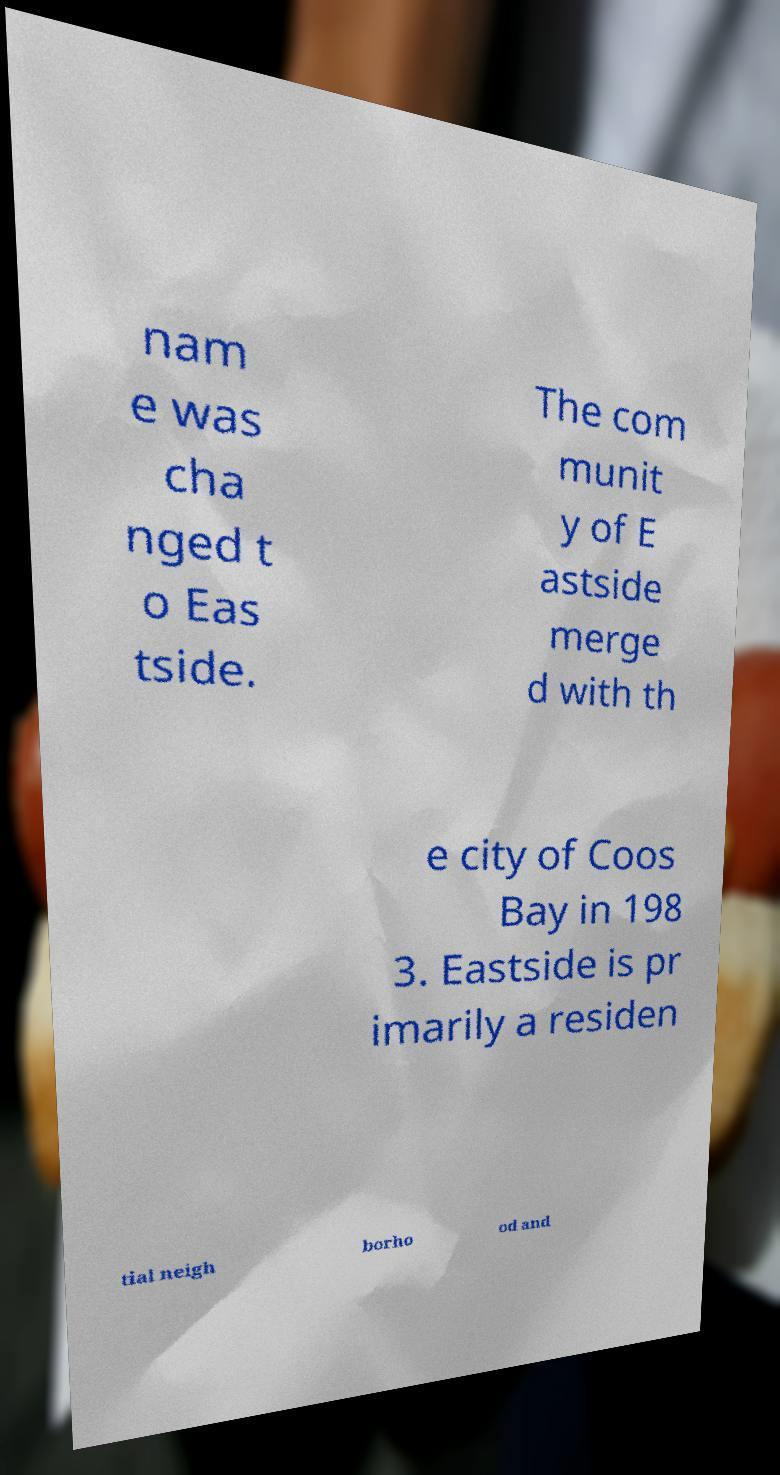Can you accurately transcribe the text from the provided image for me? nam e was cha nged t o Eas tside. The com munit y of E astside merge d with th e city of Coos Bay in 198 3. Eastside is pr imarily a residen tial neigh borho od and 